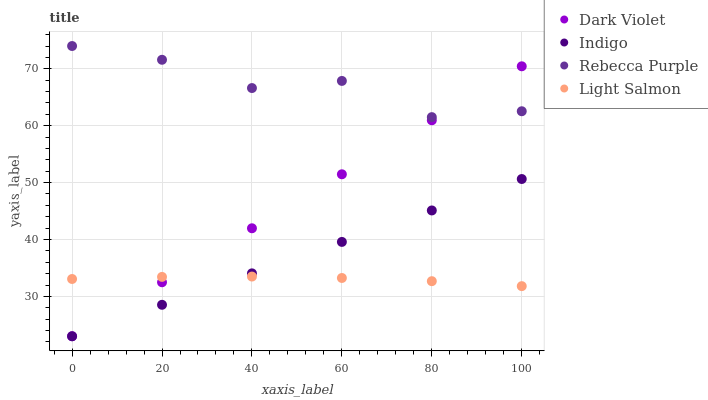Does Light Salmon have the minimum area under the curve?
Answer yes or no. Yes. Does Rebecca Purple have the maximum area under the curve?
Answer yes or no. Yes. Does Indigo have the minimum area under the curve?
Answer yes or no. No. Does Indigo have the maximum area under the curve?
Answer yes or no. No. Is Indigo the smoothest?
Answer yes or no. Yes. Is Rebecca Purple the roughest?
Answer yes or no. Yes. Is Rebecca Purple the smoothest?
Answer yes or no. No. Is Indigo the roughest?
Answer yes or no. No. Does Indigo have the lowest value?
Answer yes or no. Yes. Does Rebecca Purple have the lowest value?
Answer yes or no. No. Does Rebecca Purple have the highest value?
Answer yes or no. Yes. Does Indigo have the highest value?
Answer yes or no. No. Is Light Salmon less than Rebecca Purple?
Answer yes or no. Yes. Is Rebecca Purple greater than Indigo?
Answer yes or no. Yes. Does Dark Violet intersect Indigo?
Answer yes or no. Yes. Is Dark Violet less than Indigo?
Answer yes or no. No. Is Dark Violet greater than Indigo?
Answer yes or no. No. Does Light Salmon intersect Rebecca Purple?
Answer yes or no. No. 